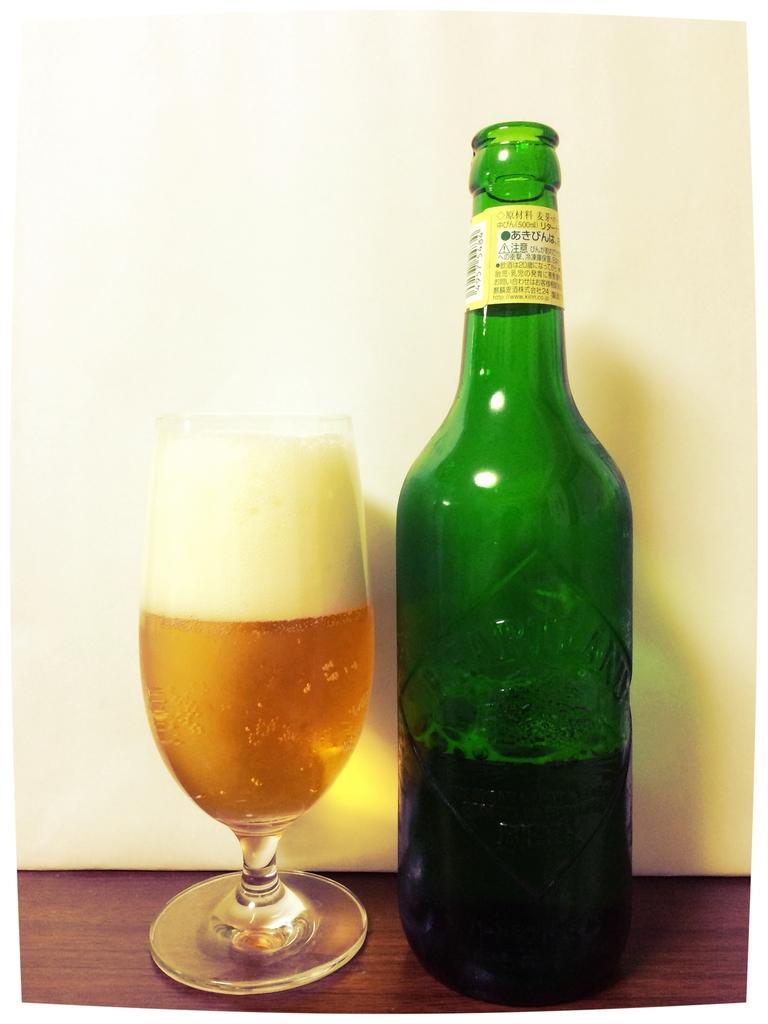In one or two sentences, can you explain what this image depicts? This is a picture, in this picture there is a green color bottle and a wine glass on a wooden table. Background of this bottle and a glass is a wall which is in white color. 